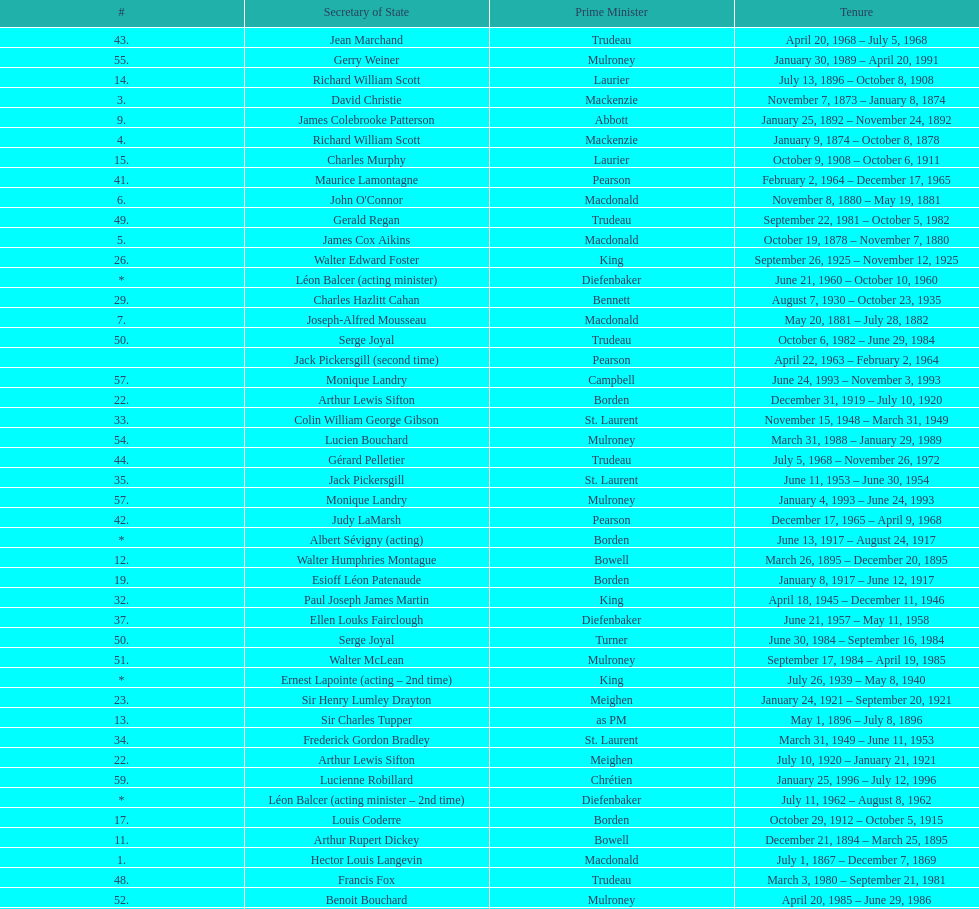How many secretaries of state had the last name bouchard? 2. 